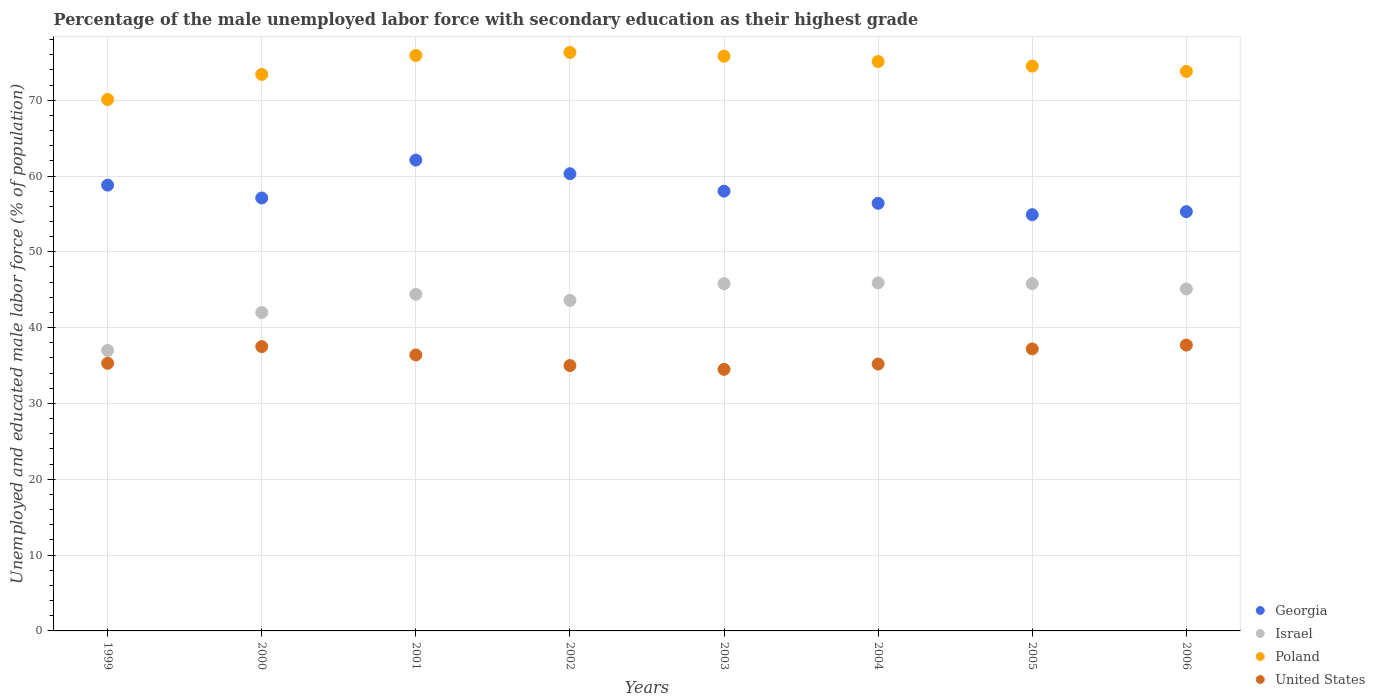How many different coloured dotlines are there?
Your response must be concise. 4. Is the number of dotlines equal to the number of legend labels?
Your response must be concise. Yes. What is the percentage of the unemployed male labor force with secondary education in Georgia in 2000?
Give a very brief answer. 57.1. Across all years, what is the maximum percentage of the unemployed male labor force with secondary education in United States?
Provide a succinct answer. 37.7. Across all years, what is the minimum percentage of the unemployed male labor force with secondary education in Poland?
Offer a terse response. 70.1. In which year was the percentage of the unemployed male labor force with secondary education in Israel maximum?
Keep it short and to the point. 2004. In which year was the percentage of the unemployed male labor force with secondary education in United States minimum?
Your answer should be compact. 2003. What is the total percentage of the unemployed male labor force with secondary education in United States in the graph?
Keep it short and to the point. 288.8. What is the difference between the percentage of the unemployed male labor force with secondary education in Israel in 2004 and that in 2006?
Provide a succinct answer. 0.8. What is the difference between the percentage of the unemployed male labor force with secondary education in Israel in 2006 and the percentage of the unemployed male labor force with secondary education in United States in 2002?
Offer a terse response. 10.1. What is the average percentage of the unemployed male labor force with secondary education in Israel per year?
Your response must be concise. 43.7. In the year 2001, what is the difference between the percentage of the unemployed male labor force with secondary education in Georgia and percentage of the unemployed male labor force with secondary education in Poland?
Give a very brief answer. -13.8. What is the ratio of the percentage of the unemployed male labor force with secondary education in United States in 2002 to that in 2006?
Keep it short and to the point. 0.93. Is the percentage of the unemployed male labor force with secondary education in United States in 1999 less than that in 2004?
Provide a succinct answer. No. Is the difference between the percentage of the unemployed male labor force with secondary education in Georgia in 2002 and 2003 greater than the difference between the percentage of the unemployed male labor force with secondary education in Poland in 2002 and 2003?
Keep it short and to the point. Yes. What is the difference between the highest and the second highest percentage of the unemployed male labor force with secondary education in Georgia?
Offer a terse response. 1.8. What is the difference between the highest and the lowest percentage of the unemployed male labor force with secondary education in Israel?
Offer a very short reply. 8.9. Is it the case that in every year, the sum of the percentage of the unemployed male labor force with secondary education in Israel and percentage of the unemployed male labor force with secondary education in Poland  is greater than the sum of percentage of the unemployed male labor force with secondary education in United States and percentage of the unemployed male labor force with secondary education in Georgia?
Your answer should be compact. No. Is it the case that in every year, the sum of the percentage of the unemployed male labor force with secondary education in United States and percentage of the unemployed male labor force with secondary education in Georgia  is greater than the percentage of the unemployed male labor force with secondary education in Israel?
Ensure brevity in your answer.  Yes. Is the percentage of the unemployed male labor force with secondary education in United States strictly less than the percentage of the unemployed male labor force with secondary education in Israel over the years?
Your answer should be very brief. Yes. How many dotlines are there?
Ensure brevity in your answer.  4. What is the difference between two consecutive major ticks on the Y-axis?
Provide a short and direct response. 10. Does the graph contain grids?
Provide a short and direct response. Yes. How many legend labels are there?
Give a very brief answer. 4. How are the legend labels stacked?
Ensure brevity in your answer.  Vertical. What is the title of the graph?
Your answer should be very brief. Percentage of the male unemployed labor force with secondary education as their highest grade. Does "Sri Lanka" appear as one of the legend labels in the graph?
Make the answer very short. No. What is the label or title of the Y-axis?
Offer a very short reply. Unemployed and educated male labor force (% of population). What is the Unemployed and educated male labor force (% of population) in Georgia in 1999?
Your answer should be very brief. 58.8. What is the Unemployed and educated male labor force (% of population) in Poland in 1999?
Your response must be concise. 70.1. What is the Unemployed and educated male labor force (% of population) in United States in 1999?
Keep it short and to the point. 35.3. What is the Unemployed and educated male labor force (% of population) of Georgia in 2000?
Make the answer very short. 57.1. What is the Unemployed and educated male labor force (% of population) in Israel in 2000?
Your response must be concise. 42. What is the Unemployed and educated male labor force (% of population) of Poland in 2000?
Offer a terse response. 73.4. What is the Unemployed and educated male labor force (% of population) of United States in 2000?
Your answer should be very brief. 37.5. What is the Unemployed and educated male labor force (% of population) in Georgia in 2001?
Offer a terse response. 62.1. What is the Unemployed and educated male labor force (% of population) in Israel in 2001?
Provide a succinct answer. 44.4. What is the Unemployed and educated male labor force (% of population) of Poland in 2001?
Your answer should be very brief. 75.9. What is the Unemployed and educated male labor force (% of population) in United States in 2001?
Provide a succinct answer. 36.4. What is the Unemployed and educated male labor force (% of population) of Georgia in 2002?
Make the answer very short. 60.3. What is the Unemployed and educated male labor force (% of population) in Israel in 2002?
Provide a short and direct response. 43.6. What is the Unemployed and educated male labor force (% of population) in Poland in 2002?
Offer a terse response. 76.3. What is the Unemployed and educated male labor force (% of population) of United States in 2002?
Make the answer very short. 35. What is the Unemployed and educated male labor force (% of population) in Israel in 2003?
Offer a very short reply. 45.8. What is the Unemployed and educated male labor force (% of population) in Poland in 2003?
Offer a very short reply. 75.8. What is the Unemployed and educated male labor force (% of population) in United States in 2003?
Your response must be concise. 34.5. What is the Unemployed and educated male labor force (% of population) in Georgia in 2004?
Your response must be concise. 56.4. What is the Unemployed and educated male labor force (% of population) of Israel in 2004?
Ensure brevity in your answer.  45.9. What is the Unemployed and educated male labor force (% of population) in Poland in 2004?
Provide a short and direct response. 75.1. What is the Unemployed and educated male labor force (% of population) of United States in 2004?
Provide a succinct answer. 35.2. What is the Unemployed and educated male labor force (% of population) in Georgia in 2005?
Your response must be concise. 54.9. What is the Unemployed and educated male labor force (% of population) in Israel in 2005?
Provide a short and direct response. 45.8. What is the Unemployed and educated male labor force (% of population) of Poland in 2005?
Ensure brevity in your answer.  74.5. What is the Unemployed and educated male labor force (% of population) in United States in 2005?
Your response must be concise. 37.2. What is the Unemployed and educated male labor force (% of population) of Georgia in 2006?
Your answer should be very brief. 55.3. What is the Unemployed and educated male labor force (% of population) of Israel in 2006?
Offer a terse response. 45.1. What is the Unemployed and educated male labor force (% of population) in Poland in 2006?
Your response must be concise. 73.8. What is the Unemployed and educated male labor force (% of population) in United States in 2006?
Ensure brevity in your answer.  37.7. Across all years, what is the maximum Unemployed and educated male labor force (% of population) in Georgia?
Your response must be concise. 62.1. Across all years, what is the maximum Unemployed and educated male labor force (% of population) in Israel?
Your answer should be very brief. 45.9. Across all years, what is the maximum Unemployed and educated male labor force (% of population) of Poland?
Your answer should be compact. 76.3. Across all years, what is the maximum Unemployed and educated male labor force (% of population) in United States?
Offer a terse response. 37.7. Across all years, what is the minimum Unemployed and educated male labor force (% of population) in Georgia?
Your answer should be compact. 54.9. Across all years, what is the minimum Unemployed and educated male labor force (% of population) of Israel?
Offer a terse response. 37. Across all years, what is the minimum Unemployed and educated male labor force (% of population) in Poland?
Ensure brevity in your answer.  70.1. Across all years, what is the minimum Unemployed and educated male labor force (% of population) of United States?
Ensure brevity in your answer.  34.5. What is the total Unemployed and educated male labor force (% of population) in Georgia in the graph?
Provide a short and direct response. 462.9. What is the total Unemployed and educated male labor force (% of population) in Israel in the graph?
Provide a succinct answer. 349.6. What is the total Unemployed and educated male labor force (% of population) of Poland in the graph?
Keep it short and to the point. 594.9. What is the total Unemployed and educated male labor force (% of population) of United States in the graph?
Keep it short and to the point. 288.8. What is the difference between the Unemployed and educated male labor force (% of population) of United States in 1999 and that in 2000?
Keep it short and to the point. -2.2. What is the difference between the Unemployed and educated male labor force (% of population) of Israel in 1999 and that in 2001?
Offer a very short reply. -7.4. What is the difference between the Unemployed and educated male labor force (% of population) of Israel in 1999 and that in 2002?
Your response must be concise. -6.6. What is the difference between the Unemployed and educated male labor force (% of population) in United States in 1999 and that in 2002?
Your answer should be compact. 0.3. What is the difference between the Unemployed and educated male labor force (% of population) of Georgia in 1999 and that in 2003?
Your answer should be compact. 0.8. What is the difference between the Unemployed and educated male labor force (% of population) of Israel in 1999 and that in 2004?
Keep it short and to the point. -8.9. What is the difference between the Unemployed and educated male labor force (% of population) in United States in 1999 and that in 2004?
Offer a very short reply. 0.1. What is the difference between the Unemployed and educated male labor force (% of population) of United States in 1999 and that in 2005?
Your answer should be compact. -1.9. What is the difference between the Unemployed and educated male labor force (% of population) of United States in 1999 and that in 2006?
Ensure brevity in your answer.  -2.4. What is the difference between the Unemployed and educated male labor force (% of population) of Georgia in 2000 and that in 2001?
Provide a short and direct response. -5. What is the difference between the Unemployed and educated male labor force (% of population) of Israel in 2000 and that in 2002?
Your answer should be compact. -1.6. What is the difference between the Unemployed and educated male labor force (% of population) of United States in 2000 and that in 2002?
Keep it short and to the point. 2.5. What is the difference between the Unemployed and educated male labor force (% of population) in Poland in 2000 and that in 2003?
Ensure brevity in your answer.  -2.4. What is the difference between the Unemployed and educated male labor force (% of population) in United States in 2000 and that in 2003?
Provide a succinct answer. 3. What is the difference between the Unemployed and educated male labor force (% of population) of Georgia in 2000 and that in 2004?
Keep it short and to the point. 0.7. What is the difference between the Unemployed and educated male labor force (% of population) of Israel in 2000 and that in 2004?
Your response must be concise. -3.9. What is the difference between the Unemployed and educated male labor force (% of population) of Georgia in 2000 and that in 2005?
Your answer should be compact. 2.2. What is the difference between the Unemployed and educated male labor force (% of population) in Israel in 2000 and that in 2005?
Keep it short and to the point. -3.8. What is the difference between the Unemployed and educated male labor force (% of population) in United States in 2000 and that in 2006?
Ensure brevity in your answer.  -0.2. What is the difference between the Unemployed and educated male labor force (% of population) in Poland in 2001 and that in 2002?
Offer a terse response. -0.4. What is the difference between the Unemployed and educated male labor force (% of population) in Poland in 2001 and that in 2003?
Your answer should be very brief. 0.1. What is the difference between the Unemployed and educated male labor force (% of population) in United States in 2001 and that in 2003?
Your response must be concise. 1.9. What is the difference between the Unemployed and educated male labor force (% of population) in Georgia in 2001 and that in 2004?
Keep it short and to the point. 5.7. What is the difference between the Unemployed and educated male labor force (% of population) in Georgia in 2001 and that in 2005?
Provide a succinct answer. 7.2. What is the difference between the Unemployed and educated male labor force (% of population) of Poland in 2001 and that in 2005?
Provide a short and direct response. 1.4. What is the difference between the Unemployed and educated male labor force (% of population) in Georgia in 2001 and that in 2006?
Provide a succinct answer. 6.8. What is the difference between the Unemployed and educated male labor force (% of population) of United States in 2001 and that in 2006?
Your answer should be compact. -1.3. What is the difference between the Unemployed and educated male labor force (% of population) in Georgia in 2002 and that in 2003?
Your response must be concise. 2.3. What is the difference between the Unemployed and educated male labor force (% of population) in United States in 2002 and that in 2003?
Provide a short and direct response. 0.5. What is the difference between the Unemployed and educated male labor force (% of population) in Israel in 2002 and that in 2004?
Offer a very short reply. -2.3. What is the difference between the Unemployed and educated male labor force (% of population) of Poland in 2002 and that in 2004?
Your answer should be compact. 1.2. What is the difference between the Unemployed and educated male labor force (% of population) of Georgia in 2002 and that in 2005?
Your answer should be very brief. 5.4. What is the difference between the Unemployed and educated male labor force (% of population) in United States in 2002 and that in 2005?
Offer a very short reply. -2.2. What is the difference between the Unemployed and educated male labor force (% of population) of Georgia in 2002 and that in 2006?
Give a very brief answer. 5. What is the difference between the Unemployed and educated male labor force (% of population) in United States in 2002 and that in 2006?
Give a very brief answer. -2.7. What is the difference between the Unemployed and educated male labor force (% of population) of Israel in 2003 and that in 2004?
Provide a short and direct response. -0.1. What is the difference between the Unemployed and educated male labor force (% of population) in United States in 2003 and that in 2004?
Your answer should be very brief. -0.7. What is the difference between the Unemployed and educated male labor force (% of population) of Poland in 2003 and that in 2006?
Ensure brevity in your answer.  2. What is the difference between the Unemployed and educated male labor force (% of population) of United States in 2003 and that in 2006?
Ensure brevity in your answer.  -3.2. What is the difference between the Unemployed and educated male labor force (% of population) of Georgia in 2004 and that in 2005?
Give a very brief answer. 1.5. What is the difference between the Unemployed and educated male labor force (% of population) of Georgia in 2004 and that in 2006?
Offer a terse response. 1.1. What is the difference between the Unemployed and educated male labor force (% of population) of Israel in 2004 and that in 2006?
Offer a terse response. 0.8. What is the difference between the Unemployed and educated male labor force (% of population) in United States in 2004 and that in 2006?
Your response must be concise. -2.5. What is the difference between the Unemployed and educated male labor force (% of population) in Georgia in 2005 and that in 2006?
Your answer should be very brief. -0.4. What is the difference between the Unemployed and educated male labor force (% of population) in Poland in 2005 and that in 2006?
Keep it short and to the point. 0.7. What is the difference between the Unemployed and educated male labor force (% of population) of Georgia in 1999 and the Unemployed and educated male labor force (% of population) of Israel in 2000?
Offer a terse response. 16.8. What is the difference between the Unemployed and educated male labor force (% of population) of Georgia in 1999 and the Unemployed and educated male labor force (% of population) of Poland in 2000?
Provide a short and direct response. -14.6. What is the difference between the Unemployed and educated male labor force (% of population) in Georgia in 1999 and the Unemployed and educated male labor force (% of population) in United States in 2000?
Keep it short and to the point. 21.3. What is the difference between the Unemployed and educated male labor force (% of population) in Israel in 1999 and the Unemployed and educated male labor force (% of population) in Poland in 2000?
Offer a terse response. -36.4. What is the difference between the Unemployed and educated male labor force (% of population) of Poland in 1999 and the Unemployed and educated male labor force (% of population) of United States in 2000?
Give a very brief answer. 32.6. What is the difference between the Unemployed and educated male labor force (% of population) of Georgia in 1999 and the Unemployed and educated male labor force (% of population) of Poland in 2001?
Provide a short and direct response. -17.1. What is the difference between the Unemployed and educated male labor force (% of population) in Georgia in 1999 and the Unemployed and educated male labor force (% of population) in United States in 2001?
Make the answer very short. 22.4. What is the difference between the Unemployed and educated male labor force (% of population) of Israel in 1999 and the Unemployed and educated male labor force (% of population) of Poland in 2001?
Offer a very short reply. -38.9. What is the difference between the Unemployed and educated male labor force (% of population) of Israel in 1999 and the Unemployed and educated male labor force (% of population) of United States in 2001?
Ensure brevity in your answer.  0.6. What is the difference between the Unemployed and educated male labor force (% of population) of Poland in 1999 and the Unemployed and educated male labor force (% of population) of United States in 2001?
Keep it short and to the point. 33.7. What is the difference between the Unemployed and educated male labor force (% of population) in Georgia in 1999 and the Unemployed and educated male labor force (% of population) in Israel in 2002?
Your response must be concise. 15.2. What is the difference between the Unemployed and educated male labor force (% of population) of Georgia in 1999 and the Unemployed and educated male labor force (% of population) of Poland in 2002?
Your answer should be very brief. -17.5. What is the difference between the Unemployed and educated male labor force (% of population) of Georgia in 1999 and the Unemployed and educated male labor force (% of population) of United States in 2002?
Provide a succinct answer. 23.8. What is the difference between the Unemployed and educated male labor force (% of population) in Israel in 1999 and the Unemployed and educated male labor force (% of population) in Poland in 2002?
Ensure brevity in your answer.  -39.3. What is the difference between the Unemployed and educated male labor force (% of population) in Israel in 1999 and the Unemployed and educated male labor force (% of population) in United States in 2002?
Make the answer very short. 2. What is the difference between the Unemployed and educated male labor force (% of population) in Poland in 1999 and the Unemployed and educated male labor force (% of population) in United States in 2002?
Offer a very short reply. 35.1. What is the difference between the Unemployed and educated male labor force (% of population) of Georgia in 1999 and the Unemployed and educated male labor force (% of population) of Israel in 2003?
Ensure brevity in your answer.  13. What is the difference between the Unemployed and educated male labor force (% of population) in Georgia in 1999 and the Unemployed and educated male labor force (% of population) in United States in 2003?
Offer a very short reply. 24.3. What is the difference between the Unemployed and educated male labor force (% of population) in Israel in 1999 and the Unemployed and educated male labor force (% of population) in Poland in 2003?
Make the answer very short. -38.8. What is the difference between the Unemployed and educated male labor force (% of population) in Israel in 1999 and the Unemployed and educated male labor force (% of population) in United States in 2003?
Keep it short and to the point. 2.5. What is the difference between the Unemployed and educated male labor force (% of population) of Poland in 1999 and the Unemployed and educated male labor force (% of population) of United States in 2003?
Your answer should be very brief. 35.6. What is the difference between the Unemployed and educated male labor force (% of population) in Georgia in 1999 and the Unemployed and educated male labor force (% of population) in Poland in 2004?
Ensure brevity in your answer.  -16.3. What is the difference between the Unemployed and educated male labor force (% of population) in Georgia in 1999 and the Unemployed and educated male labor force (% of population) in United States in 2004?
Ensure brevity in your answer.  23.6. What is the difference between the Unemployed and educated male labor force (% of population) of Israel in 1999 and the Unemployed and educated male labor force (% of population) of Poland in 2004?
Provide a short and direct response. -38.1. What is the difference between the Unemployed and educated male labor force (% of population) of Israel in 1999 and the Unemployed and educated male labor force (% of population) of United States in 2004?
Offer a terse response. 1.8. What is the difference between the Unemployed and educated male labor force (% of population) in Poland in 1999 and the Unemployed and educated male labor force (% of population) in United States in 2004?
Your answer should be very brief. 34.9. What is the difference between the Unemployed and educated male labor force (% of population) in Georgia in 1999 and the Unemployed and educated male labor force (% of population) in Israel in 2005?
Offer a very short reply. 13. What is the difference between the Unemployed and educated male labor force (% of population) in Georgia in 1999 and the Unemployed and educated male labor force (% of population) in Poland in 2005?
Provide a succinct answer. -15.7. What is the difference between the Unemployed and educated male labor force (% of population) in Georgia in 1999 and the Unemployed and educated male labor force (% of population) in United States in 2005?
Your answer should be compact. 21.6. What is the difference between the Unemployed and educated male labor force (% of population) in Israel in 1999 and the Unemployed and educated male labor force (% of population) in Poland in 2005?
Make the answer very short. -37.5. What is the difference between the Unemployed and educated male labor force (% of population) of Israel in 1999 and the Unemployed and educated male labor force (% of population) of United States in 2005?
Ensure brevity in your answer.  -0.2. What is the difference between the Unemployed and educated male labor force (% of population) of Poland in 1999 and the Unemployed and educated male labor force (% of population) of United States in 2005?
Offer a very short reply. 32.9. What is the difference between the Unemployed and educated male labor force (% of population) of Georgia in 1999 and the Unemployed and educated male labor force (% of population) of Israel in 2006?
Give a very brief answer. 13.7. What is the difference between the Unemployed and educated male labor force (% of population) of Georgia in 1999 and the Unemployed and educated male labor force (% of population) of Poland in 2006?
Ensure brevity in your answer.  -15. What is the difference between the Unemployed and educated male labor force (% of population) of Georgia in 1999 and the Unemployed and educated male labor force (% of population) of United States in 2006?
Keep it short and to the point. 21.1. What is the difference between the Unemployed and educated male labor force (% of population) in Israel in 1999 and the Unemployed and educated male labor force (% of population) in Poland in 2006?
Offer a terse response. -36.8. What is the difference between the Unemployed and educated male labor force (% of population) in Israel in 1999 and the Unemployed and educated male labor force (% of population) in United States in 2006?
Offer a terse response. -0.7. What is the difference between the Unemployed and educated male labor force (% of population) in Poland in 1999 and the Unemployed and educated male labor force (% of population) in United States in 2006?
Give a very brief answer. 32.4. What is the difference between the Unemployed and educated male labor force (% of population) of Georgia in 2000 and the Unemployed and educated male labor force (% of population) of Poland in 2001?
Keep it short and to the point. -18.8. What is the difference between the Unemployed and educated male labor force (% of population) of Georgia in 2000 and the Unemployed and educated male labor force (% of population) of United States in 2001?
Provide a succinct answer. 20.7. What is the difference between the Unemployed and educated male labor force (% of population) of Israel in 2000 and the Unemployed and educated male labor force (% of population) of Poland in 2001?
Make the answer very short. -33.9. What is the difference between the Unemployed and educated male labor force (% of population) of Israel in 2000 and the Unemployed and educated male labor force (% of population) of United States in 2001?
Your response must be concise. 5.6. What is the difference between the Unemployed and educated male labor force (% of population) of Georgia in 2000 and the Unemployed and educated male labor force (% of population) of Poland in 2002?
Offer a very short reply. -19.2. What is the difference between the Unemployed and educated male labor force (% of population) of Georgia in 2000 and the Unemployed and educated male labor force (% of population) of United States in 2002?
Provide a succinct answer. 22.1. What is the difference between the Unemployed and educated male labor force (% of population) of Israel in 2000 and the Unemployed and educated male labor force (% of population) of Poland in 2002?
Offer a terse response. -34.3. What is the difference between the Unemployed and educated male labor force (% of population) in Israel in 2000 and the Unemployed and educated male labor force (% of population) in United States in 2002?
Offer a very short reply. 7. What is the difference between the Unemployed and educated male labor force (% of population) of Poland in 2000 and the Unemployed and educated male labor force (% of population) of United States in 2002?
Your answer should be compact. 38.4. What is the difference between the Unemployed and educated male labor force (% of population) in Georgia in 2000 and the Unemployed and educated male labor force (% of population) in Israel in 2003?
Your response must be concise. 11.3. What is the difference between the Unemployed and educated male labor force (% of population) of Georgia in 2000 and the Unemployed and educated male labor force (% of population) of Poland in 2003?
Make the answer very short. -18.7. What is the difference between the Unemployed and educated male labor force (% of population) of Georgia in 2000 and the Unemployed and educated male labor force (% of population) of United States in 2003?
Offer a very short reply. 22.6. What is the difference between the Unemployed and educated male labor force (% of population) in Israel in 2000 and the Unemployed and educated male labor force (% of population) in Poland in 2003?
Keep it short and to the point. -33.8. What is the difference between the Unemployed and educated male labor force (% of population) in Israel in 2000 and the Unemployed and educated male labor force (% of population) in United States in 2003?
Keep it short and to the point. 7.5. What is the difference between the Unemployed and educated male labor force (% of population) of Poland in 2000 and the Unemployed and educated male labor force (% of population) of United States in 2003?
Make the answer very short. 38.9. What is the difference between the Unemployed and educated male labor force (% of population) of Georgia in 2000 and the Unemployed and educated male labor force (% of population) of United States in 2004?
Provide a succinct answer. 21.9. What is the difference between the Unemployed and educated male labor force (% of population) of Israel in 2000 and the Unemployed and educated male labor force (% of population) of Poland in 2004?
Offer a terse response. -33.1. What is the difference between the Unemployed and educated male labor force (% of population) in Poland in 2000 and the Unemployed and educated male labor force (% of population) in United States in 2004?
Keep it short and to the point. 38.2. What is the difference between the Unemployed and educated male labor force (% of population) of Georgia in 2000 and the Unemployed and educated male labor force (% of population) of Israel in 2005?
Your answer should be compact. 11.3. What is the difference between the Unemployed and educated male labor force (% of population) of Georgia in 2000 and the Unemployed and educated male labor force (% of population) of Poland in 2005?
Make the answer very short. -17.4. What is the difference between the Unemployed and educated male labor force (% of population) of Israel in 2000 and the Unemployed and educated male labor force (% of population) of Poland in 2005?
Offer a very short reply. -32.5. What is the difference between the Unemployed and educated male labor force (% of population) in Israel in 2000 and the Unemployed and educated male labor force (% of population) in United States in 2005?
Keep it short and to the point. 4.8. What is the difference between the Unemployed and educated male labor force (% of population) in Poland in 2000 and the Unemployed and educated male labor force (% of population) in United States in 2005?
Give a very brief answer. 36.2. What is the difference between the Unemployed and educated male labor force (% of population) of Georgia in 2000 and the Unemployed and educated male labor force (% of population) of Poland in 2006?
Make the answer very short. -16.7. What is the difference between the Unemployed and educated male labor force (% of population) in Israel in 2000 and the Unemployed and educated male labor force (% of population) in Poland in 2006?
Your response must be concise. -31.8. What is the difference between the Unemployed and educated male labor force (% of population) in Poland in 2000 and the Unemployed and educated male labor force (% of population) in United States in 2006?
Ensure brevity in your answer.  35.7. What is the difference between the Unemployed and educated male labor force (% of population) of Georgia in 2001 and the Unemployed and educated male labor force (% of population) of United States in 2002?
Provide a succinct answer. 27.1. What is the difference between the Unemployed and educated male labor force (% of population) in Israel in 2001 and the Unemployed and educated male labor force (% of population) in Poland in 2002?
Offer a very short reply. -31.9. What is the difference between the Unemployed and educated male labor force (% of population) of Poland in 2001 and the Unemployed and educated male labor force (% of population) of United States in 2002?
Provide a succinct answer. 40.9. What is the difference between the Unemployed and educated male labor force (% of population) of Georgia in 2001 and the Unemployed and educated male labor force (% of population) of Israel in 2003?
Give a very brief answer. 16.3. What is the difference between the Unemployed and educated male labor force (% of population) in Georgia in 2001 and the Unemployed and educated male labor force (% of population) in Poland in 2003?
Offer a very short reply. -13.7. What is the difference between the Unemployed and educated male labor force (% of population) of Georgia in 2001 and the Unemployed and educated male labor force (% of population) of United States in 2003?
Provide a short and direct response. 27.6. What is the difference between the Unemployed and educated male labor force (% of population) of Israel in 2001 and the Unemployed and educated male labor force (% of population) of Poland in 2003?
Give a very brief answer. -31.4. What is the difference between the Unemployed and educated male labor force (% of population) of Poland in 2001 and the Unemployed and educated male labor force (% of population) of United States in 2003?
Provide a short and direct response. 41.4. What is the difference between the Unemployed and educated male labor force (% of population) of Georgia in 2001 and the Unemployed and educated male labor force (% of population) of United States in 2004?
Make the answer very short. 26.9. What is the difference between the Unemployed and educated male labor force (% of population) of Israel in 2001 and the Unemployed and educated male labor force (% of population) of Poland in 2004?
Make the answer very short. -30.7. What is the difference between the Unemployed and educated male labor force (% of population) in Israel in 2001 and the Unemployed and educated male labor force (% of population) in United States in 2004?
Ensure brevity in your answer.  9.2. What is the difference between the Unemployed and educated male labor force (% of population) in Poland in 2001 and the Unemployed and educated male labor force (% of population) in United States in 2004?
Offer a terse response. 40.7. What is the difference between the Unemployed and educated male labor force (% of population) in Georgia in 2001 and the Unemployed and educated male labor force (% of population) in Poland in 2005?
Keep it short and to the point. -12.4. What is the difference between the Unemployed and educated male labor force (% of population) of Georgia in 2001 and the Unemployed and educated male labor force (% of population) of United States in 2005?
Provide a succinct answer. 24.9. What is the difference between the Unemployed and educated male labor force (% of population) of Israel in 2001 and the Unemployed and educated male labor force (% of population) of Poland in 2005?
Provide a succinct answer. -30.1. What is the difference between the Unemployed and educated male labor force (% of population) of Israel in 2001 and the Unemployed and educated male labor force (% of population) of United States in 2005?
Provide a succinct answer. 7.2. What is the difference between the Unemployed and educated male labor force (% of population) of Poland in 2001 and the Unemployed and educated male labor force (% of population) of United States in 2005?
Your answer should be very brief. 38.7. What is the difference between the Unemployed and educated male labor force (% of population) in Georgia in 2001 and the Unemployed and educated male labor force (% of population) in Poland in 2006?
Keep it short and to the point. -11.7. What is the difference between the Unemployed and educated male labor force (% of population) in Georgia in 2001 and the Unemployed and educated male labor force (% of population) in United States in 2006?
Offer a terse response. 24.4. What is the difference between the Unemployed and educated male labor force (% of population) in Israel in 2001 and the Unemployed and educated male labor force (% of population) in Poland in 2006?
Ensure brevity in your answer.  -29.4. What is the difference between the Unemployed and educated male labor force (% of population) of Poland in 2001 and the Unemployed and educated male labor force (% of population) of United States in 2006?
Provide a succinct answer. 38.2. What is the difference between the Unemployed and educated male labor force (% of population) of Georgia in 2002 and the Unemployed and educated male labor force (% of population) of Poland in 2003?
Ensure brevity in your answer.  -15.5. What is the difference between the Unemployed and educated male labor force (% of population) of Georgia in 2002 and the Unemployed and educated male labor force (% of population) of United States in 2003?
Provide a succinct answer. 25.8. What is the difference between the Unemployed and educated male labor force (% of population) in Israel in 2002 and the Unemployed and educated male labor force (% of population) in Poland in 2003?
Keep it short and to the point. -32.2. What is the difference between the Unemployed and educated male labor force (% of population) in Israel in 2002 and the Unemployed and educated male labor force (% of population) in United States in 2003?
Offer a terse response. 9.1. What is the difference between the Unemployed and educated male labor force (% of population) of Poland in 2002 and the Unemployed and educated male labor force (% of population) of United States in 2003?
Your answer should be compact. 41.8. What is the difference between the Unemployed and educated male labor force (% of population) in Georgia in 2002 and the Unemployed and educated male labor force (% of population) in Israel in 2004?
Offer a very short reply. 14.4. What is the difference between the Unemployed and educated male labor force (% of population) of Georgia in 2002 and the Unemployed and educated male labor force (% of population) of Poland in 2004?
Offer a very short reply. -14.8. What is the difference between the Unemployed and educated male labor force (% of population) of Georgia in 2002 and the Unemployed and educated male labor force (% of population) of United States in 2004?
Provide a succinct answer. 25.1. What is the difference between the Unemployed and educated male labor force (% of population) of Israel in 2002 and the Unemployed and educated male labor force (% of population) of Poland in 2004?
Ensure brevity in your answer.  -31.5. What is the difference between the Unemployed and educated male labor force (% of population) in Poland in 2002 and the Unemployed and educated male labor force (% of population) in United States in 2004?
Your answer should be very brief. 41.1. What is the difference between the Unemployed and educated male labor force (% of population) in Georgia in 2002 and the Unemployed and educated male labor force (% of population) in Israel in 2005?
Provide a succinct answer. 14.5. What is the difference between the Unemployed and educated male labor force (% of population) of Georgia in 2002 and the Unemployed and educated male labor force (% of population) of United States in 2005?
Your response must be concise. 23.1. What is the difference between the Unemployed and educated male labor force (% of population) in Israel in 2002 and the Unemployed and educated male labor force (% of population) in Poland in 2005?
Offer a terse response. -30.9. What is the difference between the Unemployed and educated male labor force (% of population) of Israel in 2002 and the Unemployed and educated male labor force (% of population) of United States in 2005?
Offer a terse response. 6.4. What is the difference between the Unemployed and educated male labor force (% of population) in Poland in 2002 and the Unemployed and educated male labor force (% of population) in United States in 2005?
Give a very brief answer. 39.1. What is the difference between the Unemployed and educated male labor force (% of population) of Georgia in 2002 and the Unemployed and educated male labor force (% of population) of Israel in 2006?
Make the answer very short. 15.2. What is the difference between the Unemployed and educated male labor force (% of population) in Georgia in 2002 and the Unemployed and educated male labor force (% of population) in United States in 2006?
Ensure brevity in your answer.  22.6. What is the difference between the Unemployed and educated male labor force (% of population) in Israel in 2002 and the Unemployed and educated male labor force (% of population) in Poland in 2006?
Provide a short and direct response. -30.2. What is the difference between the Unemployed and educated male labor force (% of population) in Poland in 2002 and the Unemployed and educated male labor force (% of population) in United States in 2006?
Ensure brevity in your answer.  38.6. What is the difference between the Unemployed and educated male labor force (% of population) in Georgia in 2003 and the Unemployed and educated male labor force (% of population) in Israel in 2004?
Give a very brief answer. 12.1. What is the difference between the Unemployed and educated male labor force (% of population) in Georgia in 2003 and the Unemployed and educated male labor force (% of population) in Poland in 2004?
Provide a succinct answer. -17.1. What is the difference between the Unemployed and educated male labor force (% of population) of Georgia in 2003 and the Unemployed and educated male labor force (% of population) of United States in 2004?
Give a very brief answer. 22.8. What is the difference between the Unemployed and educated male labor force (% of population) of Israel in 2003 and the Unemployed and educated male labor force (% of population) of Poland in 2004?
Give a very brief answer. -29.3. What is the difference between the Unemployed and educated male labor force (% of population) in Poland in 2003 and the Unemployed and educated male labor force (% of population) in United States in 2004?
Your answer should be very brief. 40.6. What is the difference between the Unemployed and educated male labor force (% of population) in Georgia in 2003 and the Unemployed and educated male labor force (% of population) in Poland in 2005?
Your response must be concise. -16.5. What is the difference between the Unemployed and educated male labor force (% of population) in Georgia in 2003 and the Unemployed and educated male labor force (% of population) in United States in 2005?
Keep it short and to the point. 20.8. What is the difference between the Unemployed and educated male labor force (% of population) of Israel in 2003 and the Unemployed and educated male labor force (% of population) of Poland in 2005?
Provide a short and direct response. -28.7. What is the difference between the Unemployed and educated male labor force (% of population) of Israel in 2003 and the Unemployed and educated male labor force (% of population) of United States in 2005?
Make the answer very short. 8.6. What is the difference between the Unemployed and educated male labor force (% of population) in Poland in 2003 and the Unemployed and educated male labor force (% of population) in United States in 2005?
Your answer should be very brief. 38.6. What is the difference between the Unemployed and educated male labor force (% of population) in Georgia in 2003 and the Unemployed and educated male labor force (% of population) in Israel in 2006?
Keep it short and to the point. 12.9. What is the difference between the Unemployed and educated male labor force (% of population) in Georgia in 2003 and the Unemployed and educated male labor force (% of population) in Poland in 2006?
Your answer should be very brief. -15.8. What is the difference between the Unemployed and educated male labor force (% of population) of Georgia in 2003 and the Unemployed and educated male labor force (% of population) of United States in 2006?
Ensure brevity in your answer.  20.3. What is the difference between the Unemployed and educated male labor force (% of population) of Poland in 2003 and the Unemployed and educated male labor force (% of population) of United States in 2006?
Offer a very short reply. 38.1. What is the difference between the Unemployed and educated male labor force (% of population) of Georgia in 2004 and the Unemployed and educated male labor force (% of population) of Israel in 2005?
Your answer should be compact. 10.6. What is the difference between the Unemployed and educated male labor force (% of population) of Georgia in 2004 and the Unemployed and educated male labor force (% of population) of Poland in 2005?
Provide a short and direct response. -18.1. What is the difference between the Unemployed and educated male labor force (% of population) in Georgia in 2004 and the Unemployed and educated male labor force (% of population) in United States in 2005?
Give a very brief answer. 19.2. What is the difference between the Unemployed and educated male labor force (% of population) in Israel in 2004 and the Unemployed and educated male labor force (% of population) in Poland in 2005?
Make the answer very short. -28.6. What is the difference between the Unemployed and educated male labor force (% of population) in Poland in 2004 and the Unemployed and educated male labor force (% of population) in United States in 2005?
Offer a terse response. 37.9. What is the difference between the Unemployed and educated male labor force (% of population) in Georgia in 2004 and the Unemployed and educated male labor force (% of population) in Poland in 2006?
Your answer should be very brief. -17.4. What is the difference between the Unemployed and educated male labor force (% of population) in Israel in 2004 and the Unemployed and educated male labor force (% of population) in Poland in 2006?
Your response must be concise. -27.9. What is the difference between the Unemployed and educated male labor force (% of population) in Poland in 2004 and the Unemployed and educated male labor force (% of population) in United States in 2006?
Ensure brevity in your answer.  37.4. What is the difference between the Unemployed and educated male labor force (% of population) of Georgia in 2005 and the Unemployed and educated male labor force (% of population) of Israel in 2006?
Your response must be concise. 9.8. What is the difference between the Unemployed and educated male labor force (% of population) in Georgia in 2005 and the Unemployed and educated male labor force (% of population) in Poland in 2006?
Offer a very short reply. -18.9. What is the difference between the Unemployed and educated male labor force (% of population) in Georgia in 2005 and the Unemployed and educated male labor force (% of population) in United States in 2006?
Ensure brevity in your answer.  17.2. What is the difference between the Unemployed and educated male labor force (% of population) of Poland in 2005 and the Unemployed and educated male labor force (% of population) of United States in 2006?
Keep it short and to the point. 36.8. What is the average Unemployed and educated male labor force (% of population) in Georgia per year?
Provide a succinct answer. 57.86. What is the average Unemployed and educated male labor force (% of population) in Israel per year?
Provide a short and direct response. 43.7. What is the average Unemployed and educated male labor force (% of population) of Poland per year?
Your response must be concise. 74.36. What is the average Unemployed and educated male labor force (% of population) in United States per year?
Keep it short and to the point. 36.1. In the year 1999, what is the difference between the Unemployed and educated male labor force (% of population) in Georgia and Unemployed and educated male labor force (% of population) in Israel?
Provide a succinct answer. 21.8. In the year 1999, what is the difference between the Unemployed and educated male labor force (% of population) in Georgia and Unemployed and educated male labor force (% of population) in United States?
Your response must be concise. 23.5. In the year 1999, what is the difference between the Unemployed and educated male labor force (% of population) in Israel and Unemployed and educated male labor force (% of population) in Poland?
Ensure brevity in your answer.  -33.1. In the year 1999, what is the difference between the Unemployed and educated male labor force (% of population) in Israel and Unemployed and educated male labor force (% of population) in United States?
Your answer should be very brief. 1.7. In the year 1999, what is the difference between the Unemployed and educated male labor force (% of population) of Poland and Unemployed and educated male labor force (% of population) of United States?
Make the answer very short. 34.8. In the year 2000, what is the difference between the Unemployed and educated male labor force (% of population) in Georgia and Unemployed and educated male labor force (% of population) in Israel?
Make the answer very short. 15.1. In the year 2000, what is the difference between the Unemployed and educated male labor force (% of population) in Georgia and Unemployed and educated male labor force (% of population) in Poland?
Keep it short and to the point. -16.3. In the year 2000, what is the difference between the Unemployed and educated male labor force (% of population) of Georgia and Unemployed and educated male labor force (% of population) of United States?
Offer a terse response. 19.6. In the year 2000, what is the difference between the Unemployed and educated male labor force (% of population) in Israel and Unemployed and educated male labor force (% of population) in Poland?
Provide a short and direct response. -31.4. In the year 2000, what is the difference between the Unemployed and educated male labor force (% of population) in Israel and Unemployed and educated male labor force (% of population) in United States?
Ensure brevity in your answer.  4.5. In the year 2000, what is the difference between the Unemployed and educated male labor force (% of population) in Poland and Unemployed and educated male labor force (% of population) in United States?
Offer a very short reply. 35.9. In the year 2001, what is the difference between the Unemployed and educated male labor force (% of population) in Georgia and Unemployed and educated male labor force (% of population) in Poland?
Your answer should be compact. -13.8. In the year 2001, what is the difference between the Unemployed and educated male labor force (% of population) of Georgia and Unemployed and educated male labor force (% of population) of United States?
Your answer should be very brief. 25.7. In the year 2001, what is the difference between the Unemployed and educated male labor force (% of population) of Israel and Unemployed and educated male labor force (% of population) of Poland?
Your answer should be compact. -31.5. In the year 2001, what is the difference between the Unemployed and educated male labor force (% of population) in Poland and Unemployed and educated male labor force (% of population) in United States?
Your answer should be very brief. 39.5. In the year 2002, what is the difference between the Unemployed and educated male labor force (% of population) of Georgia and Unemployed and educated male labor force (% of population) of Israel?
Provide a short and direct response. 16.7. In the year 2002, what is the difference between the Unemployed and educated male labor force (% of population) of Georgia and Unemployed and educated male labor force (% of population) of United States?
Your answer should be very brief. 25.3. In the year 2002, what is the difference between the Unemployed and educated male labor force (% of population) in Israel and Unemployed and educated male labor force (% of population) in Poland?
Your answer should be very brief. -32.7. In the year 2002, what is the difference between the Unemployed and educated male labor force (% of population) of Poland and Unemployed and educated male labor force (% of population) of United States?
Ensure brevity in your answer.  41.3. In the year 2003, what is the difference between the Unemployed and educated male labor force (% of population) in Georgia and Unemployed and educated male labor force (% of population) in Poland?
Keep it short and to the point. -17.8. In the year 2003, what is the difference between the Unemployed and educated male labor force (% of population) of Israel and Unemployed and educated male labor force (% of population) of Poland?
Offer a terse response. -30. In the year 2003, what is the difference between the Unemployed and educated male labor force (% of population) of Israel and Unemployed and educated male labor force (% of population) of United States?
Keep it short and to the point. 11.3. In the year 2003, what is the difference between the Unemployed and educated male labor force (% of population) of Poland and Unemployed and educated male labor force (% of population) of United States?
Offer a very short reply. 41.3. In the year 2004, what is the difference between the Unemployed and educated male labor force (% of population) in Georgia and Unemployed and educated male labor force (% of population) in Poland?
Offer a terse response. -18.7. In the year 2004, what is the difference between the Unemployed and educated male labor force (% of population) of Georgia and Unemployed and educated male labor force (% of population) of United States?
Your response must be concise. 21.2. In the year 2004, what is the difference between the Unemployed and educated male labor force (% of population) in Israel and Unemployed and educated male labor force (% of population) in Poland?
Ensure brevity in your answer.  -29.2. In the year 2004, what is the difference between the Unemployed and educated male labor force (% of population) of Poland and Unemployed and educated male labor force (% of population) of United States?
Your answer should be compact. 39.9. In the year 2005, what is the difference between the Unemployed and educated male labor force (% of population) of Georgia and Unemployed and educated male labor force (% of population) of Poland?
Give a very brief answer. -19.6. In the year 2005, what is the difference between the Unemployed and educated male labor force (% of population) of Georgia and Unemployed and educated male labor force (% of population) of United States?
Make the answer very short. 17.7. In the year 2005, what is the difference between the Unemployed and educated male labor force (% of population) of Israel and Unemployed and educated male labor force (% of population) of Poland?
Provide a short and direct response. -28.7. In the year 2005, what is the difference between the Unemployed and educated male labor force (% of population) in Poland and Unemployed and educated male labor force (% of population) in United States?
Your answer should be very brief. 37.3. In the year 2006, what is the difference between the Unemployed and educated male labor force (% of population) of Georgia and Unemployed and educated male labor force (% of population) of Poland?
Offer a terse response. -18.5. In the year 2006, what is the difference between the Unemployed and educated male labor force (% of population) in Georgia and Unemployed and educated male labor force (% of population) in United States?
Your answer should be compact. 17.6. In the year 2006, what is the difference between the Unemployed and educated male labor force (% of population) in Israel and Unemployed and educated male labor force (% of population) in Poland?
Offer a very short reply. -28.7. In the year 2006, what is the difference between the Unemployed and educated male labor force (% of population) in Poland and Unemployed and educated male labor force (% of population) in United States?
Give a very brief answer. 36.1. What is the ratio of the Unemployed and educated male labor force (% of population) in Georgia in 1999 to that in 2000?
Make the answer very short. 1.03. What is the ratio of the Unemployed and educated male labor force (% of population) of Israel in 1999 to that in 2000?
Your response must be concise. 0.88. What is the ratio of the Unemployed and educated male labor force (% of population) of Poland in 1999 to that in 2000?
Offer a terse response. 0.95. What is the ratio of the Unemployed and educated male labor force (% of population) of United States in 1999 to that in 2000?
Ensure brevity in your answer.  0.94. What is the ratio of the Unemployed and educated male labor force (% of population) of Georgia in 1999 to that in 2001?
Provide a succinct answer. 0.95. What is the ratio of the Unemployed and educated male labor force (% of population) in Israel in 1999 to that in 2001?
Provide a short and direct response. 0.83. What is the ratio of the Unemployed and educated male labor force (% of population) of Poland in 1999 to that in 2001?
Provide a succinct answer. 0.92. What is the ratio of the Unemployed and educated male labor force (% of population) of United States in 1999 to that in 2001?
Your response must be concise. 0.97. What is the ratio of the Unemployed and educated male labor force (% of population) of Georgia in 1999 to that in 2002?
Provide a succinct answer. 0.98. What is the ratio of the Unemployed and educated male labor force (% of population) in Israel in 1999 to that in 2002?
Your answer should be compact. 0.85. What is the ratio of the Unemployed and educated male labor force (% of population) in Poland in 1999 to that in 2002?
Give a very brief answer. 0.92. What is the ratio of the Unemployed and educated male labor force (% of population) of United States in 1999 to that in 2002?
Your answer should be compact. 1.01. What is the ratio of the Unemployed and educated male labor force (% of population) of Georgia in 1999 to that in 2003?
Make the answer very short. 1.01. What is the ratio of the Unemployed and educated male labor force (% of population) of Israel in 1999 to that in 2003?
Your response must be concise. 0.81. What is the ratio of the Unemployed and educated male labor force (% of population) in Poland in 1999 to that in 2003?
Ensure brevity in your answer.  0.92. What is the ratio of the Unemployed and educated male labor force (% of population) in United States in 1999 to that in 2003?
Provide a succinct answer. 1.02. What is the ratio of the Unemployed and educated male labor force (% of population) in Georgia in 1999 to that in 2004?
Your response must be concise. 1.04. What is the ratio of the Unemployed and educated male labor force (% of population) in Israel in 1999 to that in 2004?
Make the answer very short. 0.81. What is the ratio of the Unemployed and educated male labor force (% of population) in Poland in 1999 to that in 2004?
Your response must be concise. 0.93. What is the ratio of the Unemployed and educated male labor force (% of population) of United States in 1999 to that in 2004?
Give a very brief answer. 1. What is the ratio of the Unemployed and educated male labor force (% of population) in Georgia in 1999 to that in 2005?
Offer a very short reply. 1.07. What is the ratio of the Unemployed and educated male labor force (% of population) of Israel in 1999 to that in 2005?
Provide a short and direct response. 0.81. What is the ratio of the Unemployed and educated male labor force (% of population) in Poland in 1999 to that in 2005?
Make the answer very short. 0.94. What is the ratio of the Unemployed and educated male labor force (% of population) in United States in 1999 to that in 2005?
Keep it short and to the point. 0.95. What is the ratio of the Unemployed and educated male labor force (% of population) of Georgia in 1999 to that in 2006?
Give a very brief answer. 1.06. What is the ratio of the Unemployed and educated male labor force (% of population) of Israel in 1999 to that in 2006?
Provide a short and direct response. 0.82. What is the ratio of the Unemployed and educated male labor force (% of population) in Poland in 1999 to that in 2006?
Offer a terse response. 0.95. What is the ratio of the Unemployed and educated male labor force (% of population) of United States in 1999 to that in 2006?
Give a very brief answer. 0.94. What is the ratio of the Unemployed and educated male labor force (% of population) in Georgia in 2000 to that in 2001?
Keep it short and to the point. 0.92. What is the ratio of the Unemployed and educated male labor force (% of population) of Israel in 2000 to that in 2001?
Keep it short and to the point. 0.95. What is the ratio of the Unemployed and educated male labor force (% of population) of Poland in 2000 to that in 2001?
Keep it short and to the point. 0.97. What is the ratio of the Unemployed and educated male labor force (% of population) of United States in 2000 to that in 2001?
Your response must be concise. 1.03. What is the ratio of the Unemployed and educated male labor force (% of population) of Georgia in 2000 to that in 2002?
Ensure brevity in your answer.  0.95. What is the ratio of the Unemployed and educated male labor force (% of population) of Israel in 2000 to that in 2002?
Provide a short and direct response. 0.96. What is the ratio of the Unemployed and educated male labor force (% of population) of Poland in 2000 to that in 2002?
Ensure brevity in your answer.  0.96. What is the ratio of the Unemployed and educated male labor force (% of population) of United States in 2000 to that in 2002?
Your answer should be compact. 1.07. What is the ratio of the Unemployed and educated male labor force (% of population) in Georgia in 2000 to that in 2003?
Give a very brief answer. 0.98. What is the ratio of the Unemployed and educated male labor force (% of population) of Israel in 2000 to that in 2003?
Ensure brevity in your answer.  0.92. What is the ratio of the Unemployed and educated male labor force (% of population) in Poland in 2000 to that in 2003?
Offer a very short reply. 0.97. What is the ratio of the Unemployed and educated male labor force (% of population) in United States in 2000 to that in 2003?
Provide a succinct answer. 1.09. What is the ratio of the Unemployed and educated male labor force (% of population) in Georgia in 2000 to that in 2004?
Your answer should be compact. 1.01. What is the ratio of the Unemployed and educated male labor force (% of population) in Israel in 2000 to that in 2004?
Your response must be concise. 0.92. What is the ratio of the Unemployed and educated male labor force (% of population) of Poland in 2000 to that in 2004?
Give a very brief answer. 0.98. What is the ratio of the Unemployed and educated male labor force (% of population) of United States in 2000 to that in 2004?
Your answer should be very brief. 1.07. What is the ratio of the Unemployed and educated male labor force (% of population) of Georgia in 2000 to that in 2005?
Ensure brevity in your answer.  1.04. What is the ratio of the Unemployed and educated male labor force (% of population) of Israel in 2000 to that in 2005?
Make the answer very short. 0.92. What is the ratio of the Unemployed and educated male labor force (% of population) in Poland in 2000 to that in 2005?
Your response must be concise. 0.99. What is the ratio of the Unemployed and educated male labor force (% of population) of United States in 2000 to that in 2005?
Offer a terse response. 1.01. What is the ratio of the Unemployed and educated male labor force (% of population) in Georgia in 2000 to that in 2006?
Your answer should be very brief. 1.03. What is the ratio of the Unemployed and educated male labor force (% of population) of Israel in 2000 to that in 2006?
Make the answer very short. 0.93. What is the ratio of the Unemployed and educated male labor force (% of population) in Georgia in 2001 to that in 2002?
Offer a very short reply. 1.03. What is the ratio of the Unemployed and educated male labor force (% of population) of Israel in 2001 to that in 2002?
Your answer should be very brief. 1.02. What is the ratio of the Unemployed and educated male labor force (% of population) of United States in 2001 to that in 2002?
Your response must be concise. 1.04. What is the ratio of the Unemployed and educated male labor force (% of population) in Georgia in 2001 to that in 2003?
Offer a terse response. 1.07. What is the ratio of the Unemployed and educated male labor force (% of population) of Israel in 2001 to that in 2003?
Your response must be concise. 0.97. What is the ratio of the Unemployed and educated male labor force (% of population) in Poland in 2001 to that in 2003?
Ensure brevity in your answer.  1. What is the ratio of the Unemployed and educated male labor force (% of population) of United States in 2001 to that in 2003?
Offer a very short reply. 1.06. What is the ratio of the Unemployed and educated male labor force (% of population) in Georgia in 2001 to that in 2004?
Offer a very short reply. 1.1. What is the ratio of the Unemployed and educated male labor force (% of population) of Israel in 2001 to that in 2004?
Offer a very short reply. 0.97. What is the ratio of the Unemployed and educated male labor force (% of population) in Poland in 2001 to that in 2004?
Offer a terse response. 1.01. What is the ratio of the Unemployed and educated male labor force (% of population) in United States in 2001 to that in 2004?
Give a very brief answer. 1.03. What is the ratio of the Unemployed and educated male labor force (% of population) in Georgia in 2001 to that in 2005?
Give a very brief answer. 1.13. What is the ratio of the Unemployed and educated male labor force (% of population) in Israel in 2001 to that in 2005?
Your answer should be compact. 0.97. What is the ratio of the Unemployed and educated male labor force (% of population) of Poland in 2001 to that in 2005?
Keep it short and to the point. 1.02. What is the ratio of the Unemployed and educated male labor force (% of population) in United States in 2001 to that in 2005?
Offer a terse response. 0.98. What is the ratio of the Unemployed and educated male labor force (% of population) in Georgia in 2001 to that in 2006?
Your answer should be very brief. 1.12. What is the ratio of the Unemployed and educated male labor force (% of population) of Israel in 2001 to that in 2006?
Give a very brief answer. 0.98. What is the ratio of the Unemployed and educated male labor force (% of population) of Poland in 2001 to that in 2006?
Your response must be concise. 1.03. What is the ratio of the Unemployed and educated male labor force (% of population) in United States in 2001 to that in 2006?
Give a very brief answer. 0.97. What is the ratio of the Unemployed and educated male labor force (% of population) of Georgia in 2002 to that in 2003?
Provide a short and direct response. 1.04. What is the ratio of the Unemployed and educated male labor force (% of population) in Poland in 2002 to that in 2003?
Your response must be concise. 1.01. What is the ratio of the Unemployed and educated male labor force (% of population) of United States in 2002 to that in 2003?
Your answer should be compact. 1.01. What is the ratio of the Unemployed and educated male labor force (% of population) in Georgia in 2002 to that in 2004?
Keep it short and to the point. 1.07. What is the ratio of the Unemployed and educated male labor force (% of population) of Israel in 2002 to that in 2004?
Provide a short and direct response. 0.95. What is the ratio of the Unemployed and educated male labor force (% of population) in Poland in 2002 to that in 2004?
Your response must be concise. 1.02. What is the ratio of the Unemployed and educated male labor force (% of population) in United States in 2002 to that in 2004?
Give a very brief answer. 0.99. What is the ratio of the Unemployed and educated male labor force (% of population) in Georgia in 2002 to that in 2005?
Make the answer very short. 1.1. What is the ratio of the Unemployed and educated male labor force (% of population) of Israel in 2002 to that in 2005?
Offer a very short reply. 0.95. What is the ratio of the Unemployed and educated male labor force (% of population) of Poland in 2002 to that in 2005?
Provide a succinct answer. 1.02. What is the ratio of the Unemployed and educated male labor force (% of population) in United States in 2002 to that in 2005?
Your answer should be compact. 0.94. What is the ratio of the Unemployed and educated male labor force (% of population) of Georgia in 2002 to that in 2006?
Give a very brief answer. 1.09. What is the ratio of the Unemployed and educated male labor force (% of population) in Israel in 2002 to that in 2006?
Your answer should be very brief. 0.97. What is the ratio of the Unemployed and educated male labor force (% of population) in Poland in 2002 to that in 2006?
Make the answer very short. 1.03. What is the ratio of the Unemployed and educated male labor force (% of population) in United States in 2002 to that in 2006?
Offer a terse response. 0.93. What is the ratio of the Unemployed and educated male labor force (% of population) in Georgia in 2003 to that in 2004?
Your answer should be very brief. 1.03. What is the ratio of the Unemployed and educated male labor force (% of population) in Israel in 2003 to that in 2004?
Your response must be concise. 1. What is the ratio of the Unemployed and educated male labor force (% of population) in Poland in 2003 to that in 2004?
Keep it short and to the point. 1.01. What is the ratio of the Unemployed and educated male labor force (% of population) of United States in 2003 to that in 2004?
Ensure brevity in your answer.  0.98. What is the ratio of the Unemployed and educated male labor force (% of population) in Georgia in 2003 to that in 2005?
Ensure brevity in your answer.  1.06. What is the ratio of the Unemployed and educated male labor force (% of population) in Israel in 2003 to that in 2005?
Offer a very short reply. 1. What is the ratio of the Unemployed and educated male labor force (% of population) in Poland in 2003 to that in 2005?
Your answer should be compact. 1.02. What is the ratio of the Unemployed and educated male labor force (% of population) in United States in 2003 to that in 2005?
Your answer should be very brief. 0.93. What is the ratio of the Unemployed and educated male labor force (% of population) in Georgia in 2003 to that in 2006?
Your answer should be compact. 1.05. What is the ratio of the Unemployed and educated male labor force (% of population) in Israel in 2003 to that in 2006?
Offer a terse response. 1.02. What is the ratio of the Unemployed and educated male labor force (% of population) of Poland in 2003 to that in 2006?
Your answer should be compact. 1.03. What is the ratio of the Unemployed and educated male labor force (% of population) in United States in 2003 to that in 2006?
Ensure brevity in your answer.  0.92. What is the ratio of the Unemployed and educated male labor force (% of population) in Georgia in 2004 to that in 2005?
Make the answer very short. 1.03. What is the ratio of the Unemployed and educated male labor force (% of population) in Israel in 2004 to that in 2005?
Provide a short and direct response. 1. What is the ratio of the Unemployed and educated male labor force (% of population) of Poland in 2004 to that in 2005?
Provide a succinct answer. 1.01. What is the ratio of the Unemployed and educated male labor force (% of population) of United States in 2004 to that in 2005?
Make the answer very short. 0.95. What is the ratio of the Unemployed and educated male labor force (% of population) of Georgia in 2004 to that in 2006?
Give a very brief answer. 1.02. What is the ratio of the Unemployed and educated male labor force (% of population) of Israel in 2004 to that in 2006?
Offer a very short reply. 1.02. What is the ratio of the Unemployed and educated male labor force (% of population) in Poland in 2004 to that in 2006?
Give a very brief answer. 1.02. What is the ratio of the Unemployed and educated male labor force (% of population) in United States in 2004 to that in 2006?
Make the answer very short. 0.93. What is the ratio of the Unemployed and educated male labor force (% of population) in Georgia in 2005 to that in 2006?
Keep it short and to the point. 0.99. What is the ratio of the Unemployed and educated male labor force (% of population) in Israel in 2005 to that in 2006?
Provide a succinct answer. 1.02. What is the ratio of the Unemployed and educated male labor force (% of population) of Poland in 2005 to that in 2006?
Your answer should be compact. 1.01. What is the ratio of the Unemployed and educated male labor force (% of population) of United States in 2005 to that in 2006?
Your response must be concise. 0.99. What is the difference between the highest and the second highest Unemployed and educated male labor force (% of population) in Georgia?
Provide a succinct answer. 1.8. What is the difference between the highest and the second highest Unemployed and educated male labor force (% of population) of Poland?
Make the answer very short. 0.4. What is the difference between the highest and the lowest Unemployed and educated male labor force (% of population) of Israel?
Keep it short and to the point. 8.9. What is the difference between the highest and the lowest Unemployed and educated male labor force (% of population) of Poland?
Your answer should be very brief. 6.2. 